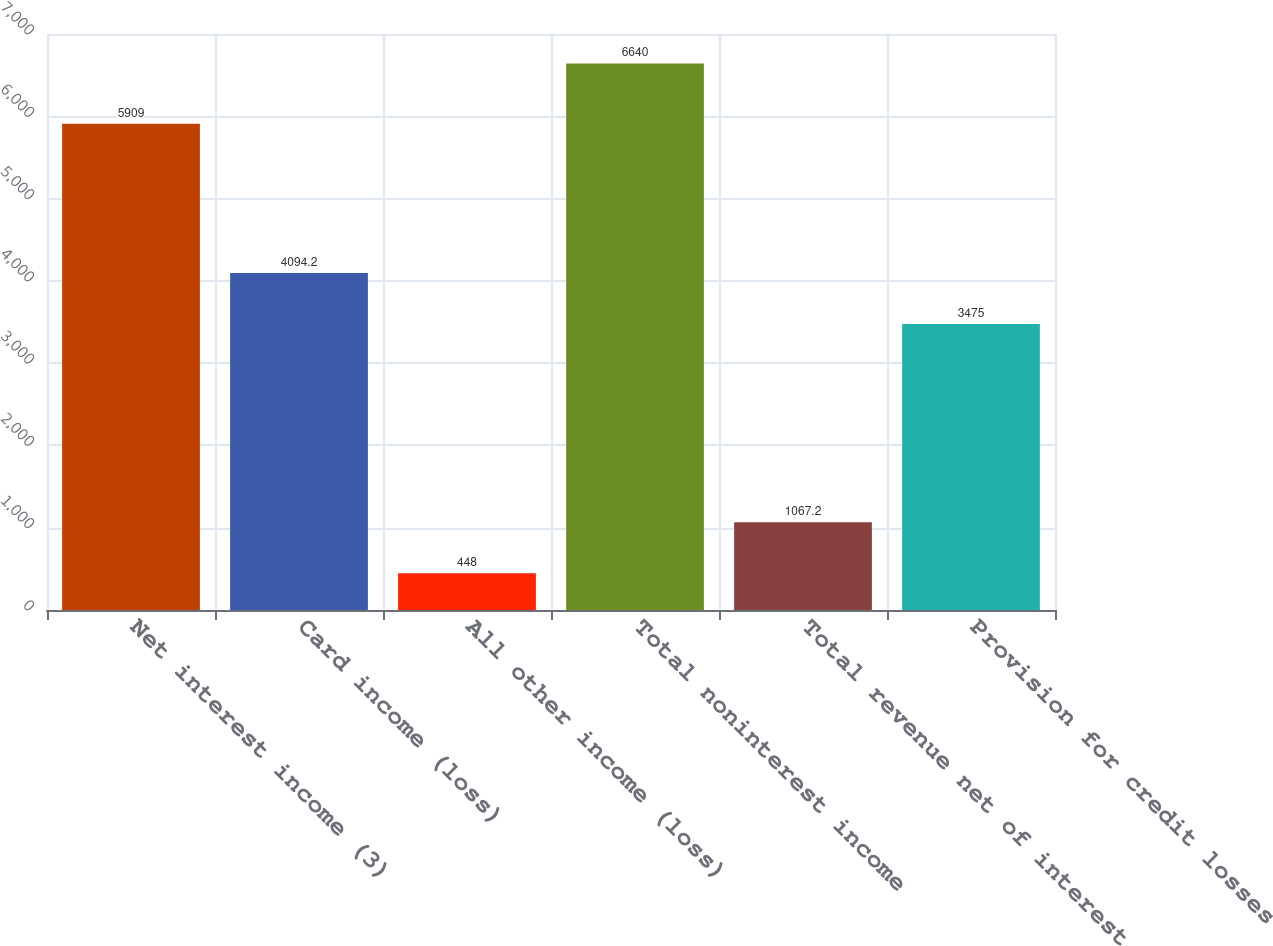Convert chart to OTSL. <chart><loc_0><loc_0><loc_500><loc_500><bar_chart><fcel>Net interest income (3)<fcel>Card income (loss)<fcel>All other income (loss)<fcel>Total noninterest income<fcel>Total revenue net of interest<fcel>Provision for credit losses<nl><fcel>5909<fcel>4094.2<fcel>448<fcel>6640<fcel>1067.2<fcel>3475<nl></chart> 